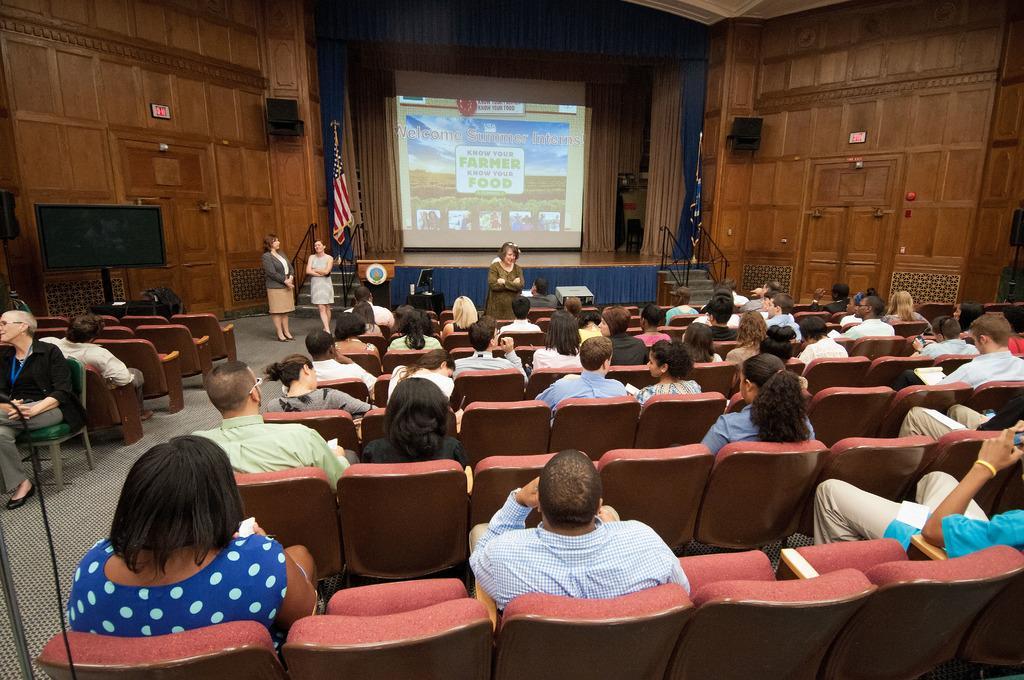Can you describe this image briefly? Here few people are sitting on the chairs and looking at this side. On the left side 2 women are standing, in the middle it is a projected screen. 